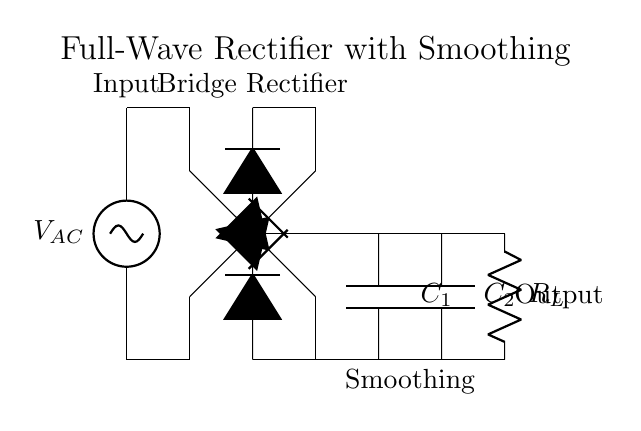What is the type of rectifier used in this circuit? The circuit uses a full-wave rectifier, evident from the configuration of the diodes arranged in a bridge circuit. This configuration allows both halves of the AC input to be utilized for charging the output capacitor.
Answer: full-wave rectifier How many diodes are used in the bridge rectifier? The bridge rectifier consists of four diodes connected in a specific arrangement that allows for full-wave rectification of the alternating current. This ensures that both the positive and negative cycles of the AC voltage contribute to the output.
Answer: four What is the purpose of the capacitors in this circuit? The capacitors serve to smooth the output voltage by filtering the ripples caused by the rectification process, which is crucial for reducing hum in audio equipment. They temporarily store charge and release it to maintain a more stable voltage.
Answer: smoothing What is the load component in this circuit? The load component is the resistor labeled as R_L, which represents the device or circuit that consumes the rectified output voltage from this rectifier. It is crucial for indicating the load that the rectifier is designed to drive.
Answer: resistor What connection is made to the input voltage? The connection to the input voltage is shown going into the first diode in the bridge rectifier. This configuration absorbs and converts the alternating current into direct current by allowing current to flow through depending on the polarity.
Answer: AC source What is the expected output type of this rectifier circuit? The expected output type is direct current, as indicated by the bridging of the diodes which converts the alternating current from the input to direct current suitable for audio equipment.
Answer: direct current 